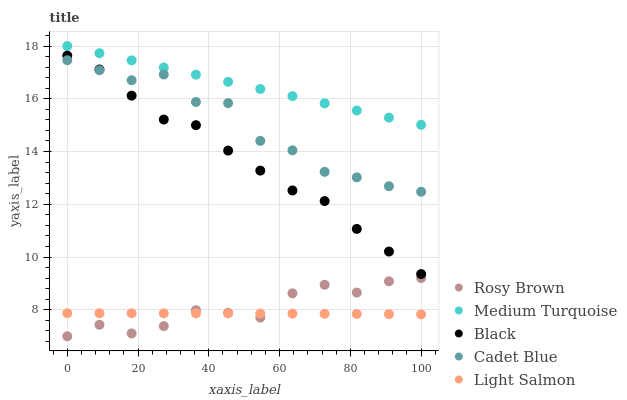Does Light Salmon have the minimum area under the curve?
Answer yes or no. Yes. Does Medium Turquoise have the maximum area under the curve?
Answer yes or no. Yes. Does Rosy Brown have the minimum area under the curve?
Answer yes or no. No. Does Rosy Brown have the maximum area under the curve?
Answer yes or no. No. Is Medium Turquoise the smoothest?
Answer yes or no. Yes. Is Cadet Blue the roughest?
Answer yes or no. Yes. Is Light Salmon the smoothest?
Answer yes or no. No. Is Light Salmon the roughest?
Answer yes or no. No. Does Rosy Brown have the lowest value?
Answer yes or no. Yes. Does Light Salmon have the lowest value?
Answer yes or no. No. Does Medium Turquoise have the highest value?
Answer yes or no. Yes. Does Rosy Brown have the highest value?
Answer yes or no. No. Is Cadet Blue less than Medium Turquoise?
Answer yes or no. Yes. Is Black greater than Rosy Brown?
Answer yes or no. Yes. Does Cadet Blue intersect Black?
Answer yes or no. Yes. Is Cadet Blue less than Black?
Answer yes or no. No. Is Cadet Blue greater than Black?
Answer yes or no. No. Does Cadet Blue intersect Medium Turquoise?
Answer yes or no. No. 